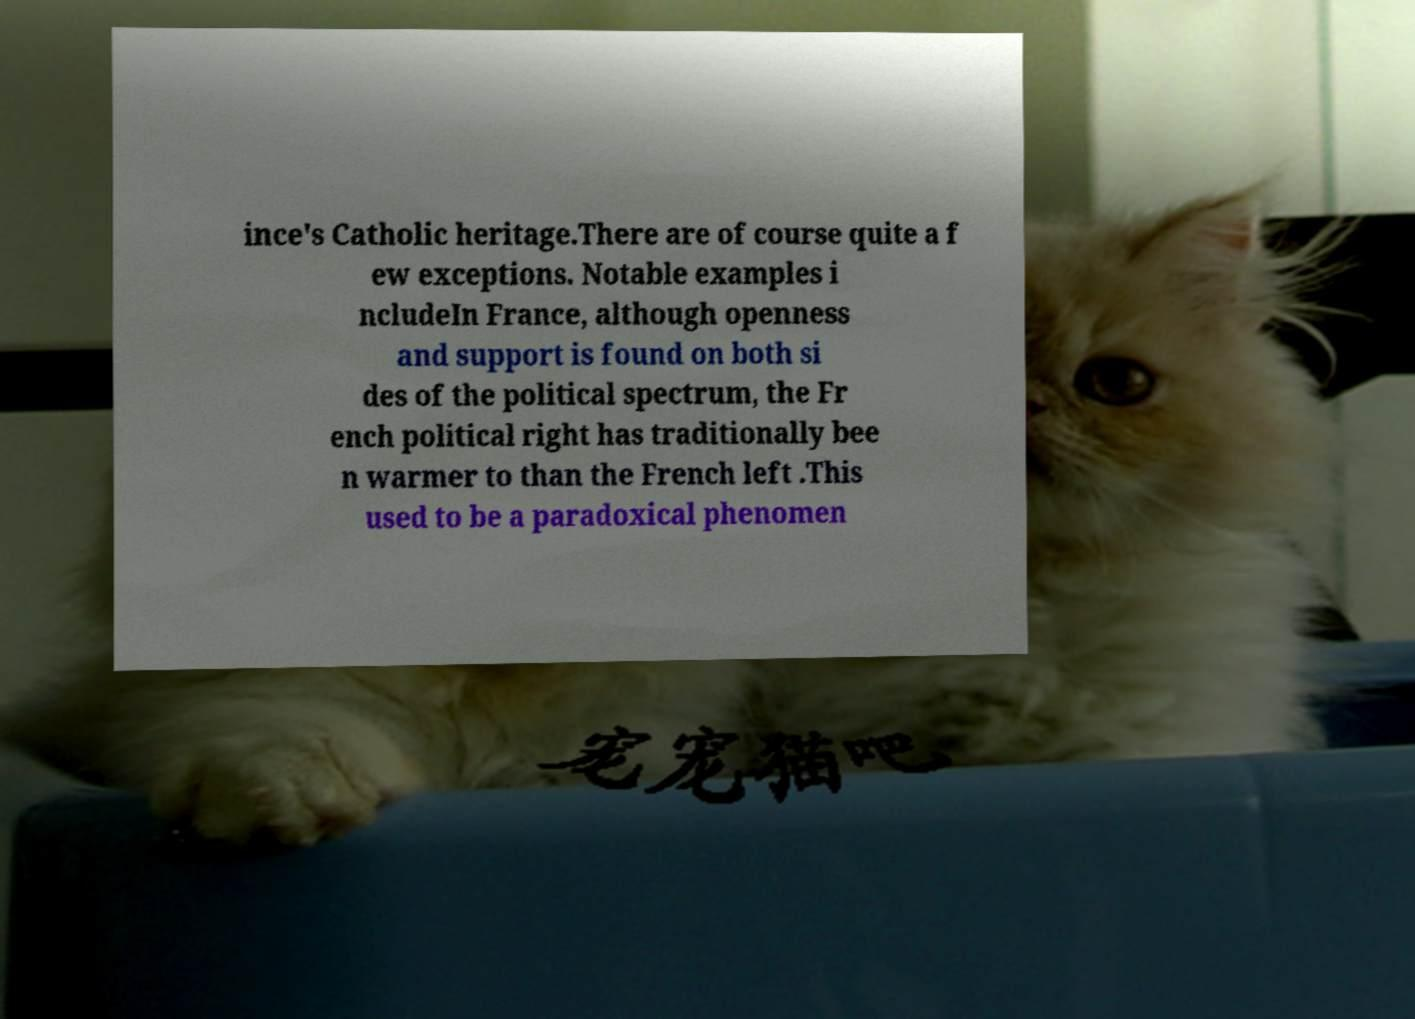Can you read and provide the text displayed in the image?This photo seems to have some interesting text. Can you extract and type it out for me? ince's Catholic heritage.There are of course quite a f ew exceptions. Notable examples i ncludeIn France, although openness and support is found on both si des of the political spectrum, the Fr ench political right has traditionally bee n warmer to than the French left .This used to be a paradoxical phenomen 